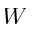<formula> <loc_0><loc_0><loc_500><loc_500>W</formula> 